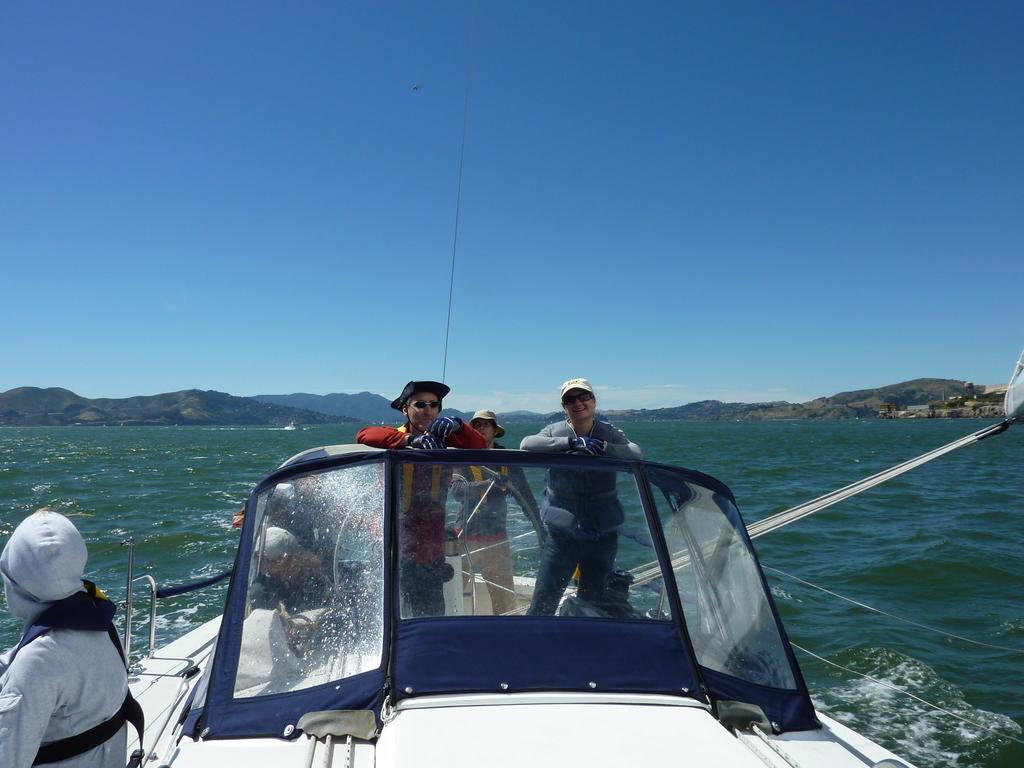Please provide a concise description of this image. In this image I can see a boat which is white and black in color on the surface of the water and few persons standing on the boat. In the background I can see the water, few mountains and the sky. 